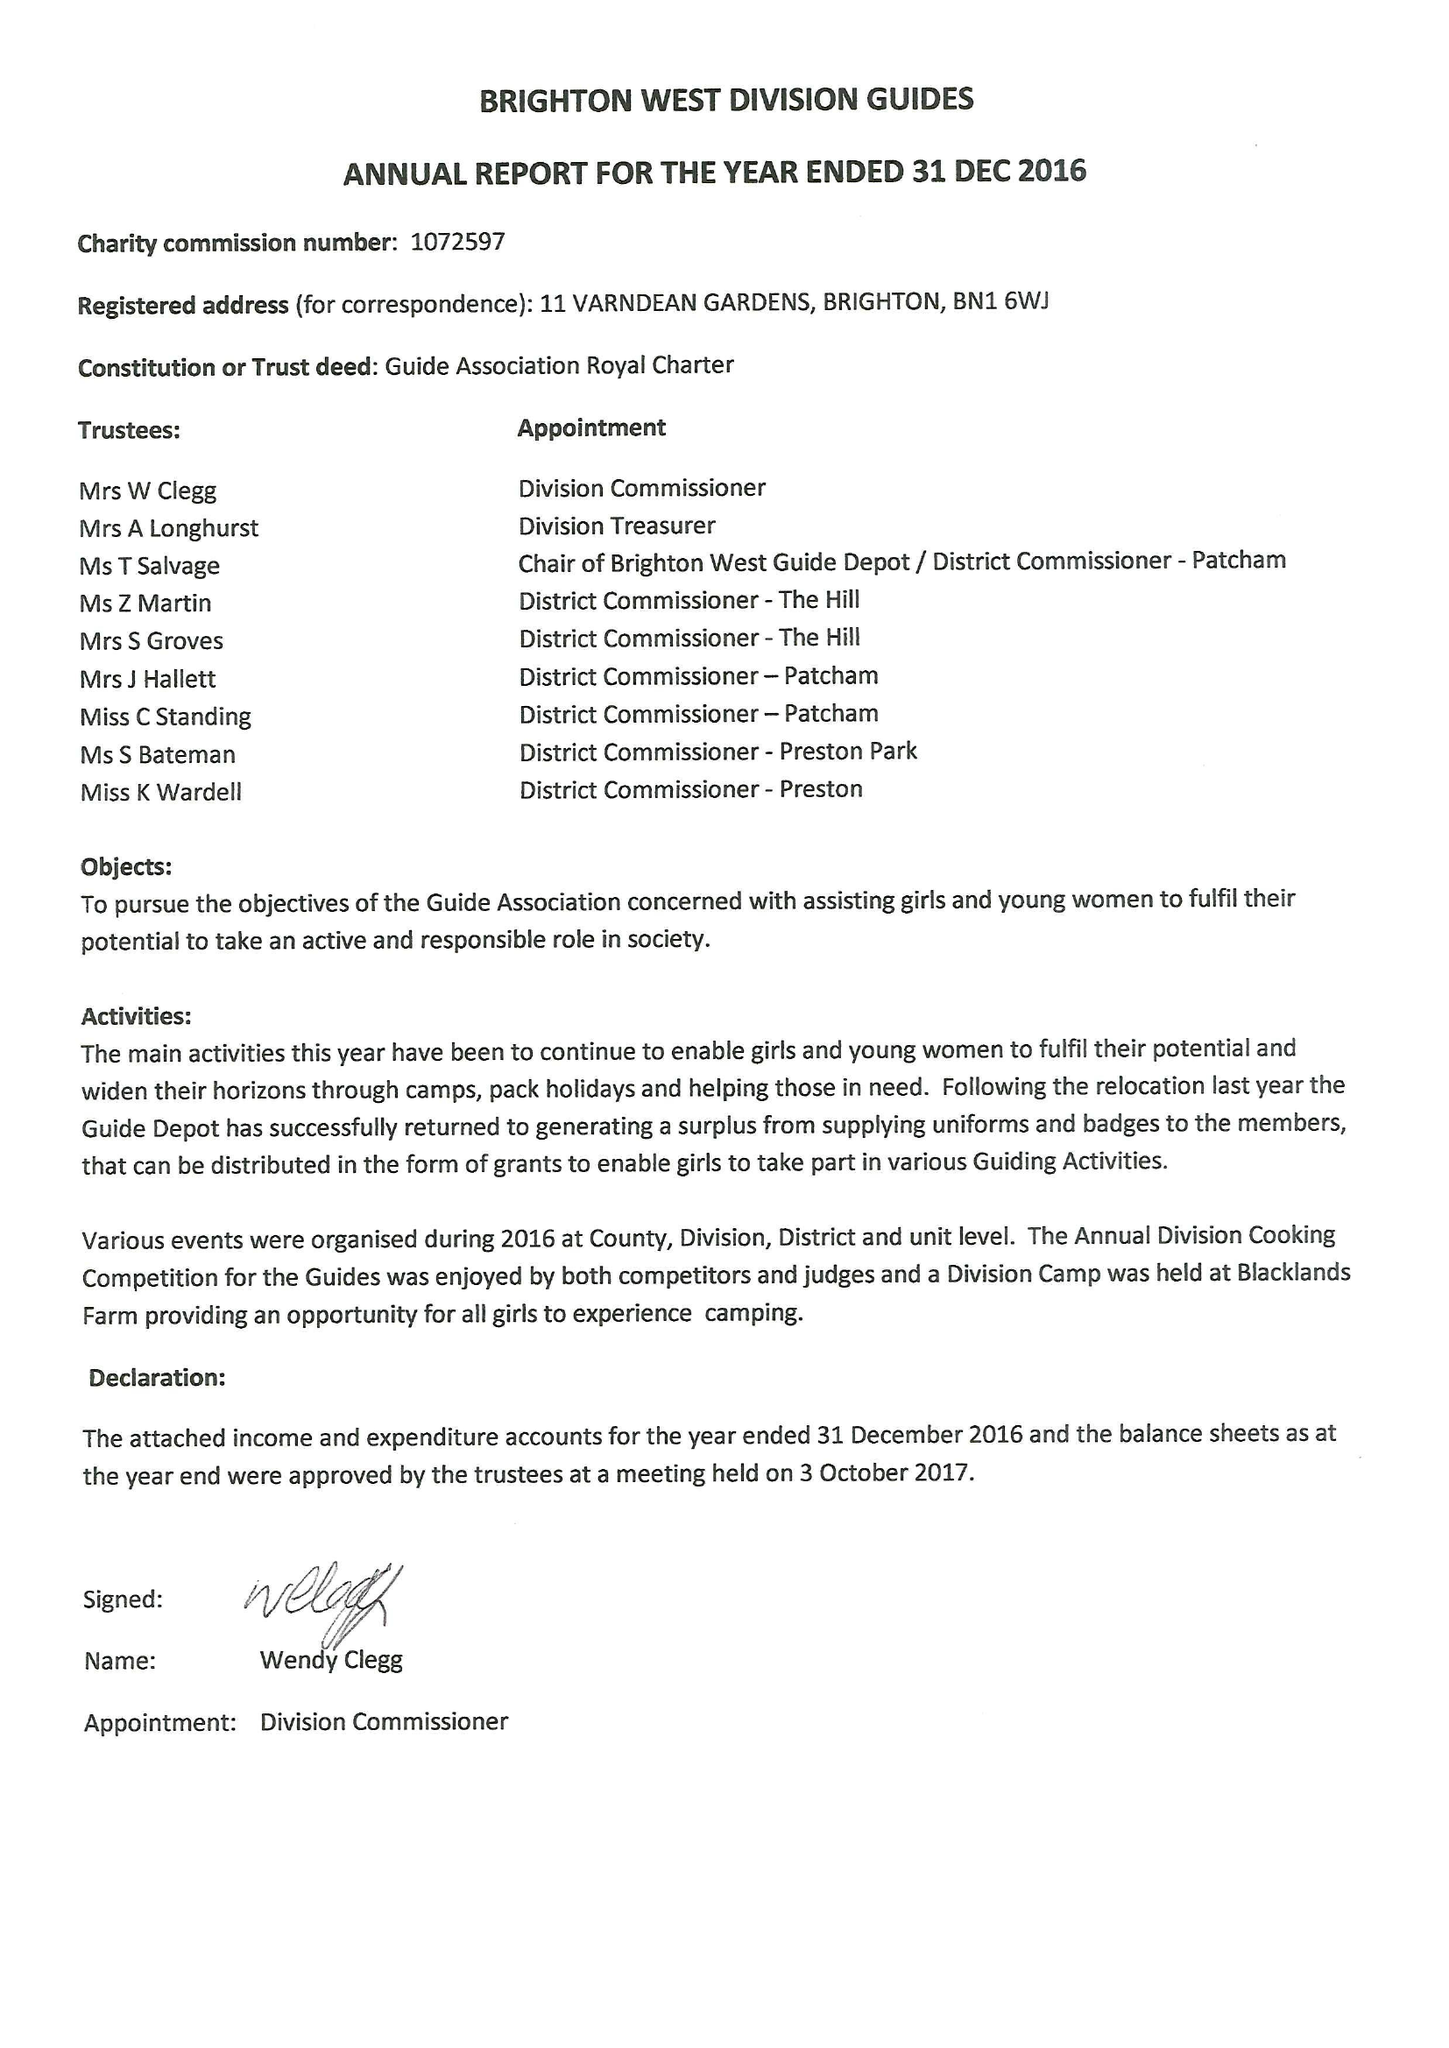What is the value for the spending_annually_in_british_pounds?
Answer the question using a single word or phrase. 31844.00 